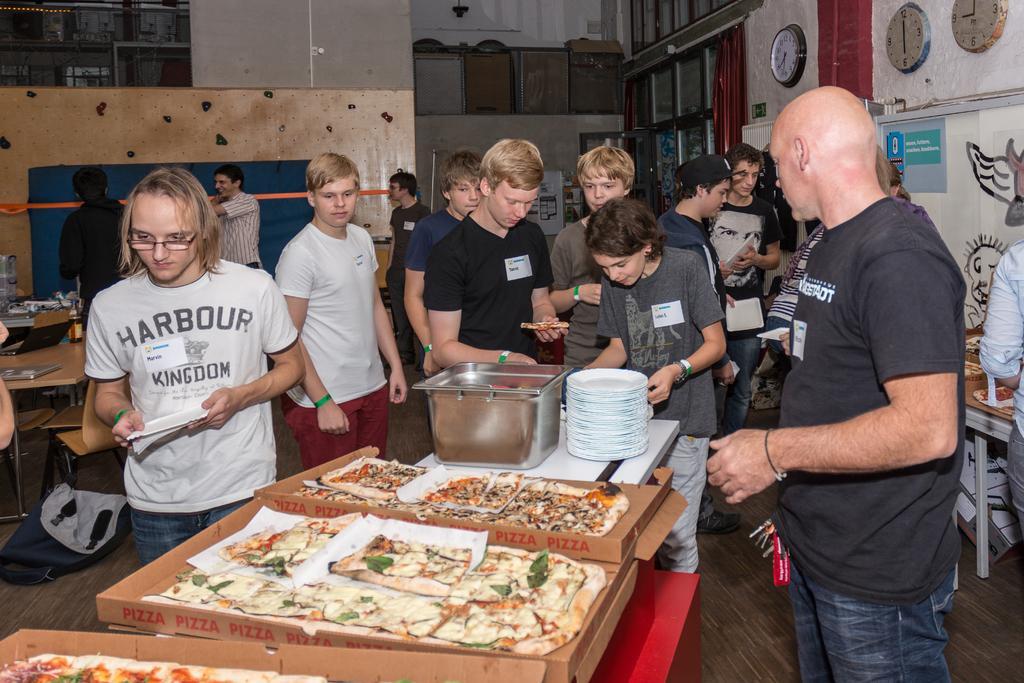Can you describe this image briefly? In this image I can see a crowd of people visible on the floor and I can see benches and on benches I can see trays , on trays I can see food item and on top of bench I can see plates and container and I can see the wall , on the wall I can see clocks attached on the right side. 